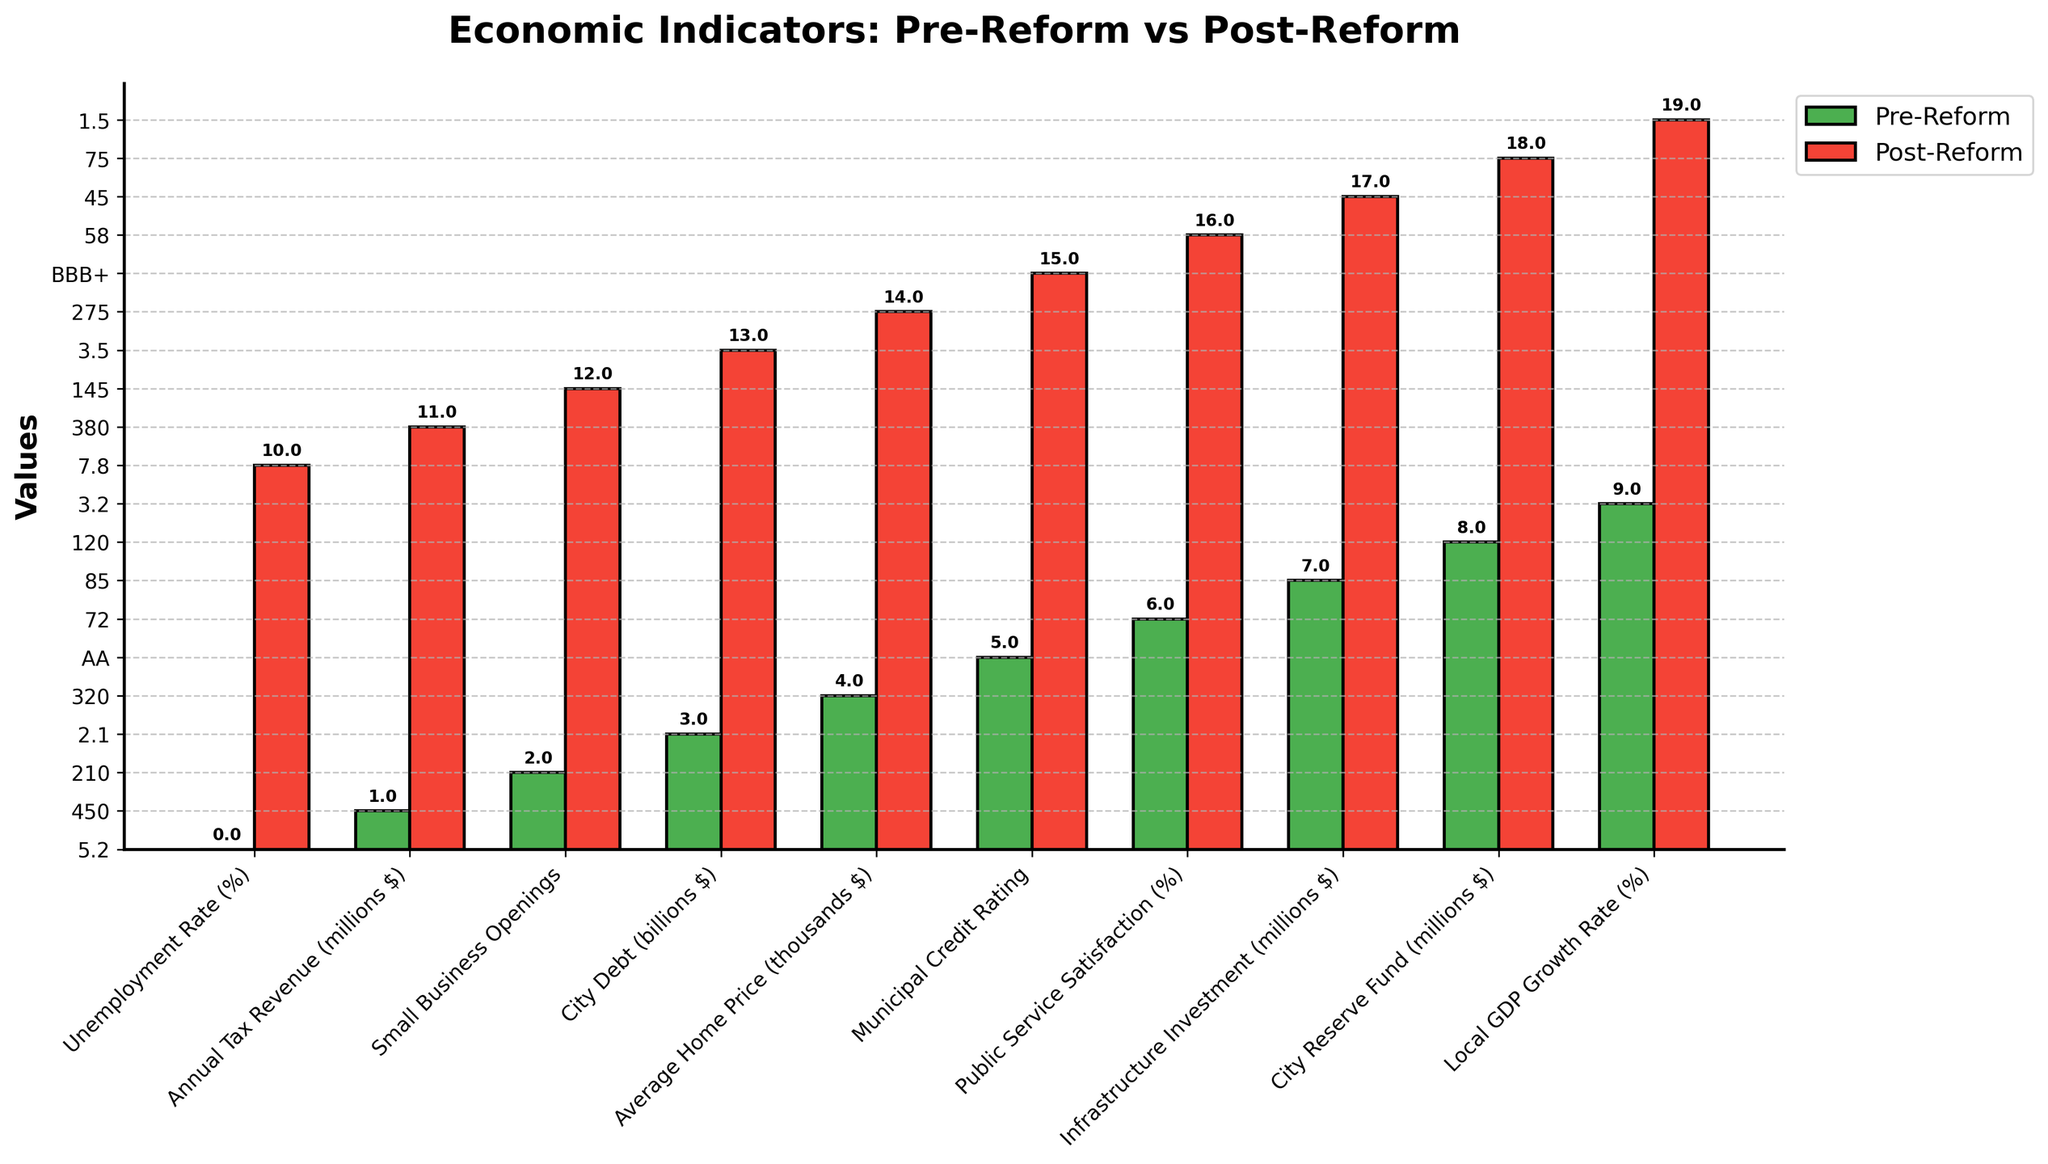What is the change in Unemployment Rate from pre-reform to post-reform? The Unemployment Rate pre-reform is 5.2%, and post-reform is 7.8%. To find the change, subtract the pre-reform rate from the post-reform rate: 7.8% - 5.2% = 2.6%.
Answer: 2.6% How does the City's Debt compare before and after the reform? Pre-reform City Debt is $2.1 billion, while post-reform City Debt is $3.5 billion. The post-reform debt is greater than the pre-reform debt by 3.5 - 2.1 = $1.4 billion.
Answer: $1.4 billion Which period, pre-reform or post-reform, has a higher Public Service Satisfaction percentage? The bar chart indicates that Public Service Satisfaction is 72% pre-reform and 58% post-reform. 72% is higher than 58%.
Answer: Pre-reform By how much did the Average Home Price drop from pre-reform to post-reform? The Average Home Price pre-reform is $320,000, and post-reform is $275,000. The drop is calculated by subtracting post-reform price from pre-reform price: 320,000 - 275,000 = $45,000.
Answer: $45,000 Is the Local GDP Growth Rate higher in the pre-reform period or the post-reform period? The Local GDP Growth Rate is 3.2% pre-reform and 1.5% post-reform, indicating a higher growth rate in the pre-reform period.
Answer: Pre-reform Calculate the total infrastructure investment over both periods. Infrastructure Investment is $85 million pre-reform and $45 million post-reform. Adding these gives: 85 + 45 = $130 million.
Answer: $130 million What is the magnitude of the decrease in Annual Tax Revenue due to the reforms? Annual Tax Revenue is $450 million pre-reform and $380 million post-reform. The decrease is 450 - 380 = $70 million.
Answer: $70 million By what percentage did Small Business Openings decrease post-reform? Small Business Openings are 210 pre-reform and 145 post-reform. The decrease is calculated as: ((210 - 145) / 210) * 100 = 30.95%.
Answer: 30.95% How does the City's Reserve Fund amount compare before and after the reform? The City Reserve Fund is $120 million pre-reform and $75 million post-reform. The pre-reform amount is higher than the post-reform amount by 120 - 75 = $45 million.
Answer: $45 million Compare the Municipal Credit Rating before and after the reform. Pre-reform, the Municipal Credit Rating is AA, whereas post-reform it is BBB+. AA is a higher credit rating than BBB+.
Answer: AA 